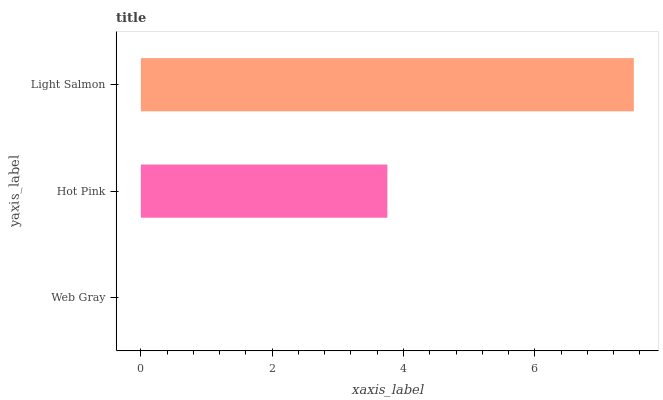Is Web Gray the minimum?
Answer yes or no. Yes. Is Light Salmon the maximum?
Answer yes or no. Yes. Is Hot Pink the minimum?
Answer yes or no. No. Is Hot Pink the maximum?
Answer yes or no. No. Is Hot Pink greater than Web Gray?
Answer yes or no. Yes. Is Web Gray less than Hot Pink?
Answer yes or no. Yes. Is Web Gray greater than Hot Pink?
Answer yes or no. No. Is Hot Pink less than Web Gray?
Answer yes or no. No. Is Hot Pink the high median?
Answer yes or no. Yes. Is Hot Pink the low median?
Answer yes or no. Yes. Is Light Salmon the high median?
Answer yes or no. No. Is Light Salmon the low median?
Answer yes or no. No. 